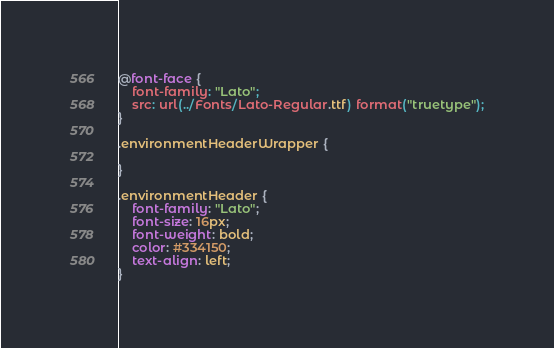<code> <loc_0><loc_0><loc_500><loc_500><_CSS_>@font-face {
    font-family: "Lato";
    src: url(../Fonts/Lato-Regular.ttf) format("truetype");
}

.environmentHeaderWrapper {

}

.environmentHeader {
    font-family: "Lato";
    font-size: 16px;
    font-weight: bold;
    color: #334150;
    text-align: left;
}</code> 